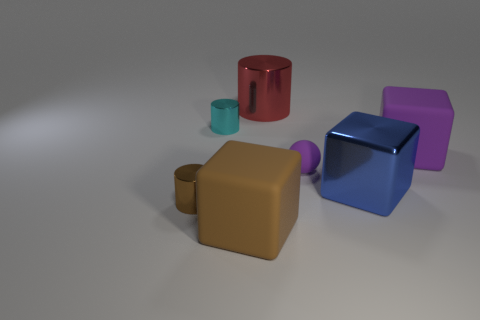What is the block that is right of the blue metallic object made of?
Your answer should be compact. Rubber. There is a matte block that is to the right of the large brown matte block that is left of the matte cube that is behind the large brown matte block; what size is it?
Ensure brevity in your answer.  Large. There is a cyan cylinder; does it have the same size as the block to the left of the red object?
Make the answer very short. No. What color is the matte thing in front of the ball?
Provide a short and direct response. Brown. The rubber thing that is the same color as the small ball is what shape?
Provide a succinct answer. Cube. The small metallic thing left of the cyan cylinder has what shape?
Offer a very short reply. Cylinder. How many purple things are big cubes or small cylinders?
Make the answer very short. 1. Does the large blue object have the same material as the cyan thing?
Make the answer very short. Yes. There is a tiny purple sphere; how many big metallic things are in front of it?
Ensure brevity in your answer.  1. What is the tiny thing that is left of the brown block and on the right side of the brown cylinder made of?
Ensure brevity in your answer.  Metal. 